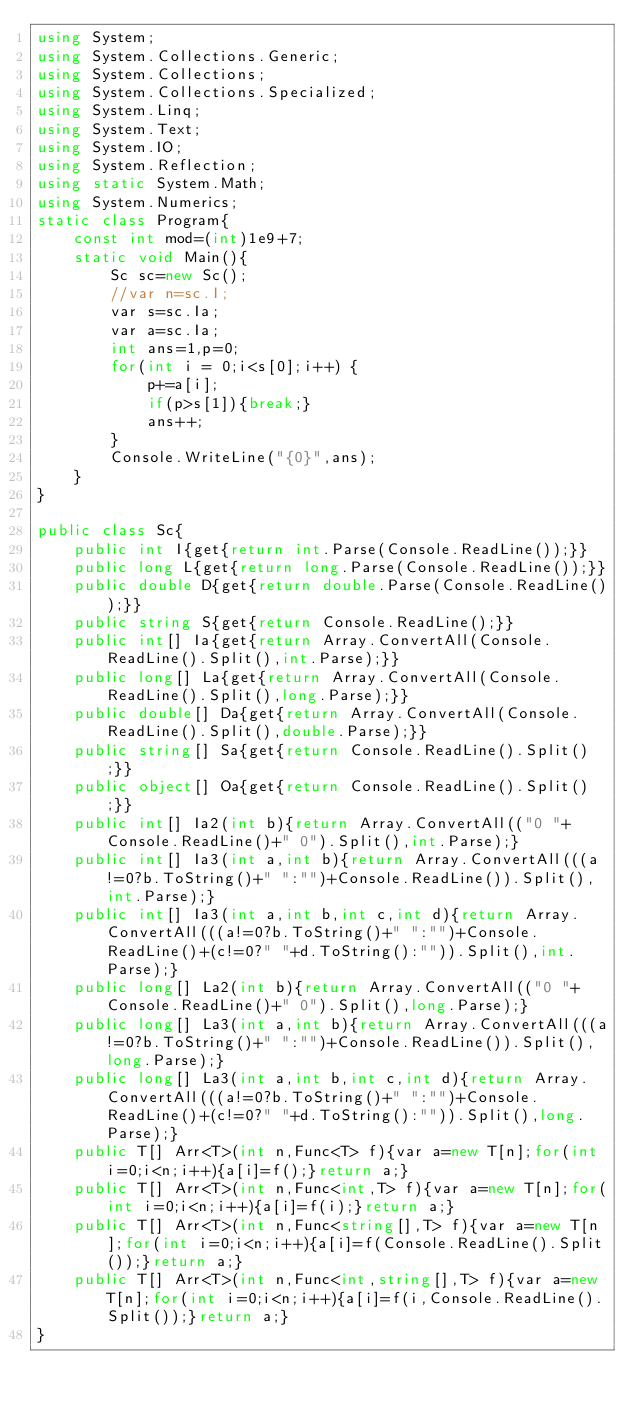<code> <loc_0><loc_0><loc_500><loc_500><_C#_>using System;
using System.Collections.Generic;
using System.Collections;
using System.Collections.Specialized;
using System.Linq;
using System.Text;
using System.IO;
using System.Reflection;
using static System.Math;
using System.Numerics;
static class Program{
	const int mod=(int)1e9+7;
	static void Main(){
		Sc sc=new Sc();
		//var n=sc.I;
		var s=sc.Ia;
		var a=sc.Ia;
		int ans=1,p=0;
		for(int i = 0;i<s[0];i++) {
			p+=a[i];
			if(p>s[1]){break;}
			ans++;
		}
		Console.WriteLine("{0}",ans);
	}
}

public class Sc{
	public int I{get{return int.Parse(Console.ReadLine());}}
	public long L{get{return long.Parse(Console.ReadLine());}}
	public double D{get{return double.Parse(Console.ReadLine());}}
	public string S{get{return Console.ReadLine();}}
	public int[] Ia{get{return Array.ConvertAll(Console.ReadLine().Split(),int.Parse);}}
	public long[] La{get{return Array.ConvertAll(Console.ReadLine().Split(),long.Parse);}}
	public double[] Da{get{return Array.ConvertAll(Console.ReadLine().Split(),double.Parse);}}
	public string[] Sa{get{return Console.ReadLine().Split();}}
	public object[] Oa{get{return Console.ReadLine().Split();}}
	public int[] Ia2(int b){return Array.ConvertAll(("0 "+Console.ReadLine()+" 0").Split(),int.Parse);}
	public int[] Ia3(int a,int b){return Array.ConvertAll(((a!=0?b.ToString()+" ":"")+Console.ReadLine()).Split(),int.Parse);}
	public int[] Ia3(int a,int b,int c,int d){return Array.ConvertAll(((a!=0?b.ToString()+" ":"")+Console.ReadLine()+(c!=0?" "+d.ToString():"")).Split(),int.Parse);}
	public long[] La2(int b){return Array.ConvertAll(("0 "+Console.ReadLine()+" 0").Split(),long.Parse);}
	public long[] La3(int a,int b){return Array.ConvertAll(((a!=0?b.ToString()+" ":"")+Console.ReadLine()).Split(),long.Parse);}
	public long[] La3(int a,int b,int c,int d){return Array.ConvertAll(((a!=0?b.ToString()+" ":"")+Console.ReadLine()+(c!=0?" "+d.ToString():"")).Split(),long.Parse);}
	public T[] Arr<T>(int n,Func<T> f){var a=new T[n];for(int i=0;i<n;i++){a[i]=f();}return a;}
	public T[] Arr<T>(int n,Func<int,T> f){var a=new T[n];for(int i=0;i<n;i++){a[i]=f(i);}return a;}
	public T[] Arr<T>(int n,Func<string[],T> f){var a=new T[n];for(int i=0;i<n;i++){a[i]=f(Console.ReadLine().Split());}return a;}
	public T[] Arr<T>(int n,Func<int,string[],T> f){var a=new T[n];for(int i=0;i<n;i++){a[i]=f(i,Console.ReadLine().Split());}return a;}
}</code> 